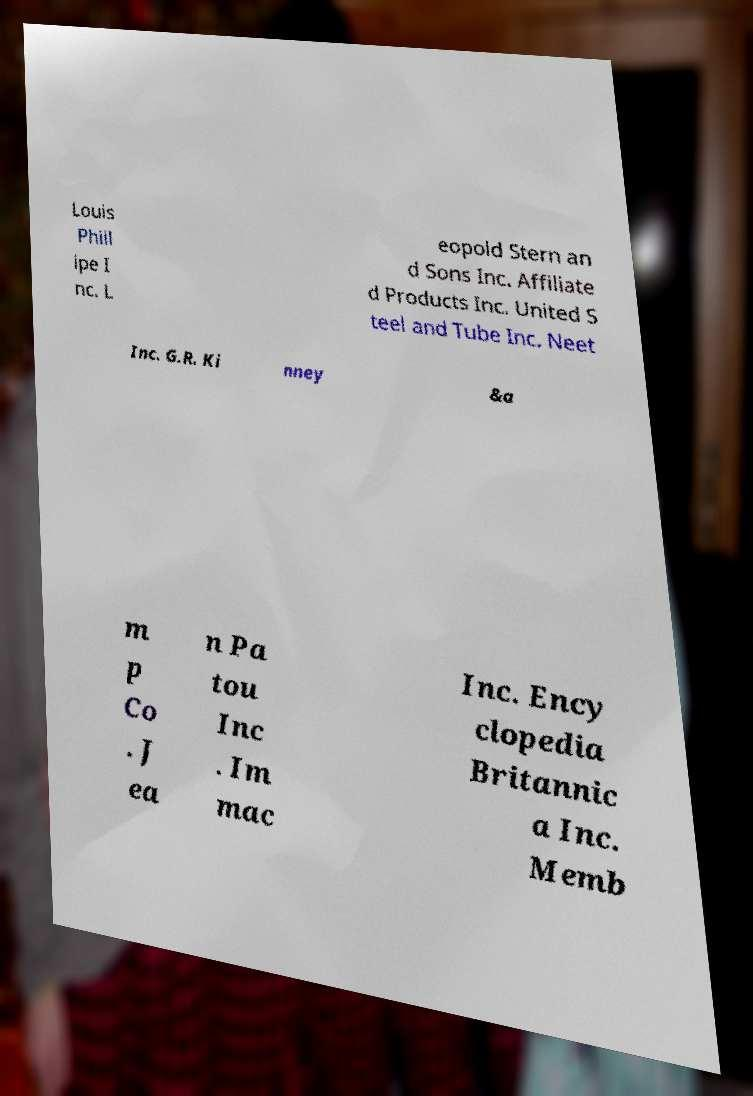Please identify and transcribe the text found in this image. Louis Phill ipe I nc. L eopold Stern an d Sons Inc. Affiliate d Products Inc. United S teel and Tube Inc. Neet Inc. G.R. Ki nney &a m p Co . J ea n Pa tou Inc . Im mac Inc. Ency clopedia Britannic a Inc. Memb 